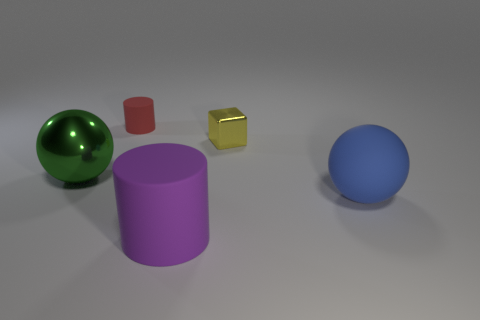Add 3 tiny brown metal blocks. How many objects exist? 8 Subtract all blocks. How many objects are left? 4 Subtract 1 spheres. How many spheres are left? 1 Subtract 0 blue cylinders. How many objects are left? 5 Subtract all red cylinders. Subtract all cyan balls. How many cylinders are left? 1 Subtract all green balls. How many purple cylinders are left? 1 Subtract all large red metal objects. Subtract all blue matte balls. How many objects are left? 4 Add 4 green metallic things. How many green metallic things are left? 5 Add 4 yellow shiny things. How many yellow shiny things exist? 5 